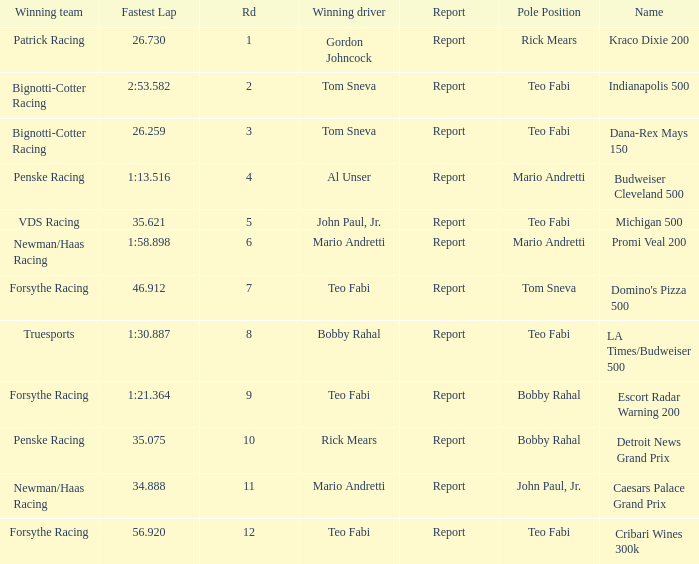Which Rd took place at the Indianapolis 500? 2.0. Could you parse the entire table? {'header': ['Winning team', 'Fastest Lap', 'Rd', 'Winning driver', 'Report', 'Pole Position', 'Name'], 'rows': [['Patrick Racing', '26.730', '1', 'Gordon Johncock', 'Report', 'Rick Mears', 'Kraco Dixie 200'], ['Bignotti-Cotter Racing', '2:53.582', '2', 'Tom Sneva', 'Report', 'Teo Fabi', 'Indianapolis 500'], ['Bignotti-Cotter Racing', '26.259', '3', 'Tom Sneva', 'Report', 'Teo Fabi', 'Dana-Rex Mays 150'], ['Penske Racing', '1:13.516', '4', 'Al Unser', 'Report', 'Mario Andretti', 'Budweiser Cleveland 500'], ['VDS Racing', '35.621', '5', 'John Paul, Jr.', 'Report', 'Teo Fabi', 'Michigan 500'], ['Newman/Haas Racing', '1:58.898', '6', 'Mario Andretti', 'Report', 'Mario Andretti', 'Promi Veal 200'], ['Forsythe Racing', '46.912', '7', 'Teo Fabi', 'Report', 'Tom Sneva', "Domino's Pizza 500"], ['Truesports', '1:30.887', '8', 'Bobby Rahal', 'Report', 'Teo Fabi', 'LA Times/Budweiser 500'], ['Forsythe Racing', '1:21.364', '9', 'Teo Fabi', 'Report', 'Bobby Rahal', 'Escort Radar Warning 200'], ['Penske Racing', '35.075', '10', 'Rick Mears', 'Report', 'Bobby Rahal', 'Detroit News Grand Prix'], ['Newman/Haas Racing', '34.888', '11', 'Mario Andretti', 'Report', 'John Paul, Jr.', 'Caesars Palace Grand Prix'], ['Forsythe Racing', '56.920', '12', 'Teo Fabi', 'Report', 'Teo Fabi', 'Cribari Wines 300k']]} 